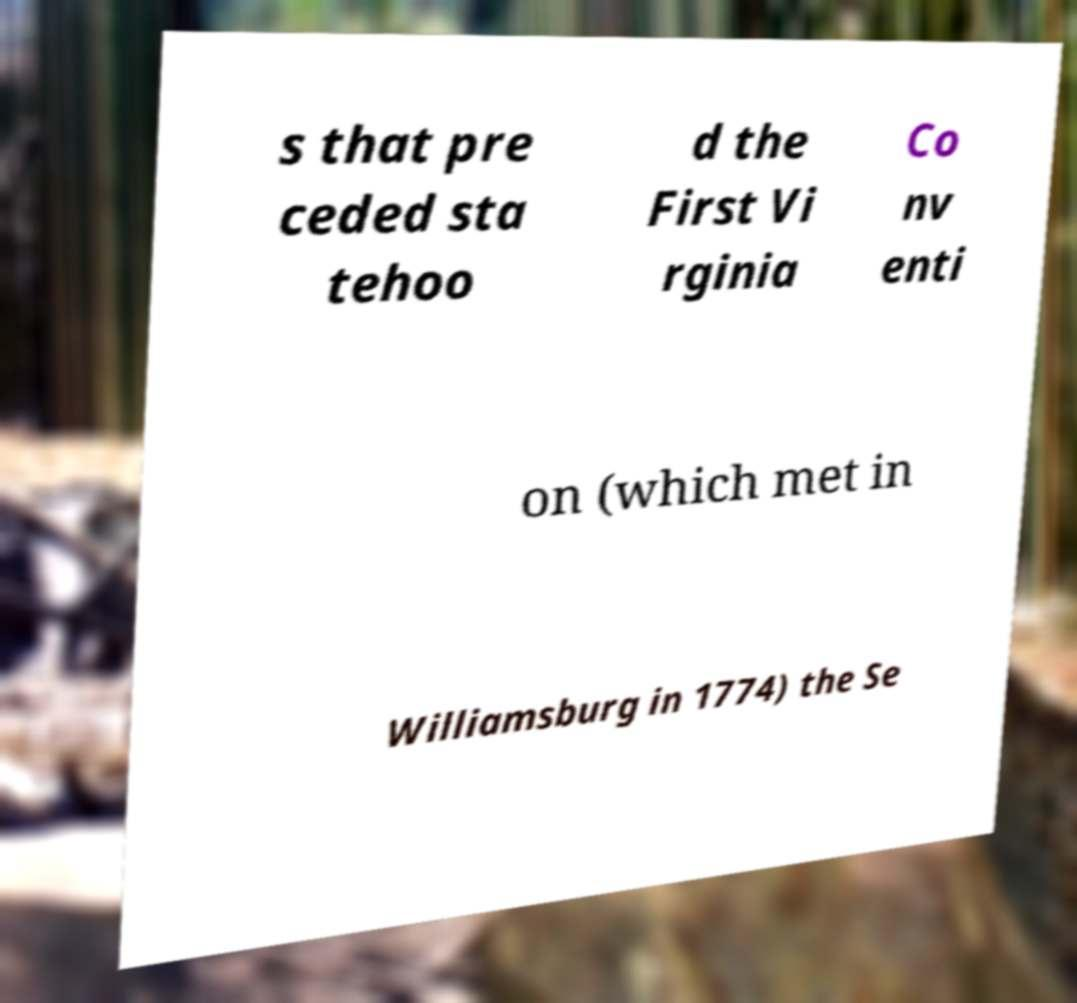Could you assist in decoding the text presented in this image and type it out clearly? s that pre ceded sta tehoo d the First Vi rginia Co nv enti on (which met in Williamsburg in 1774) the Se 